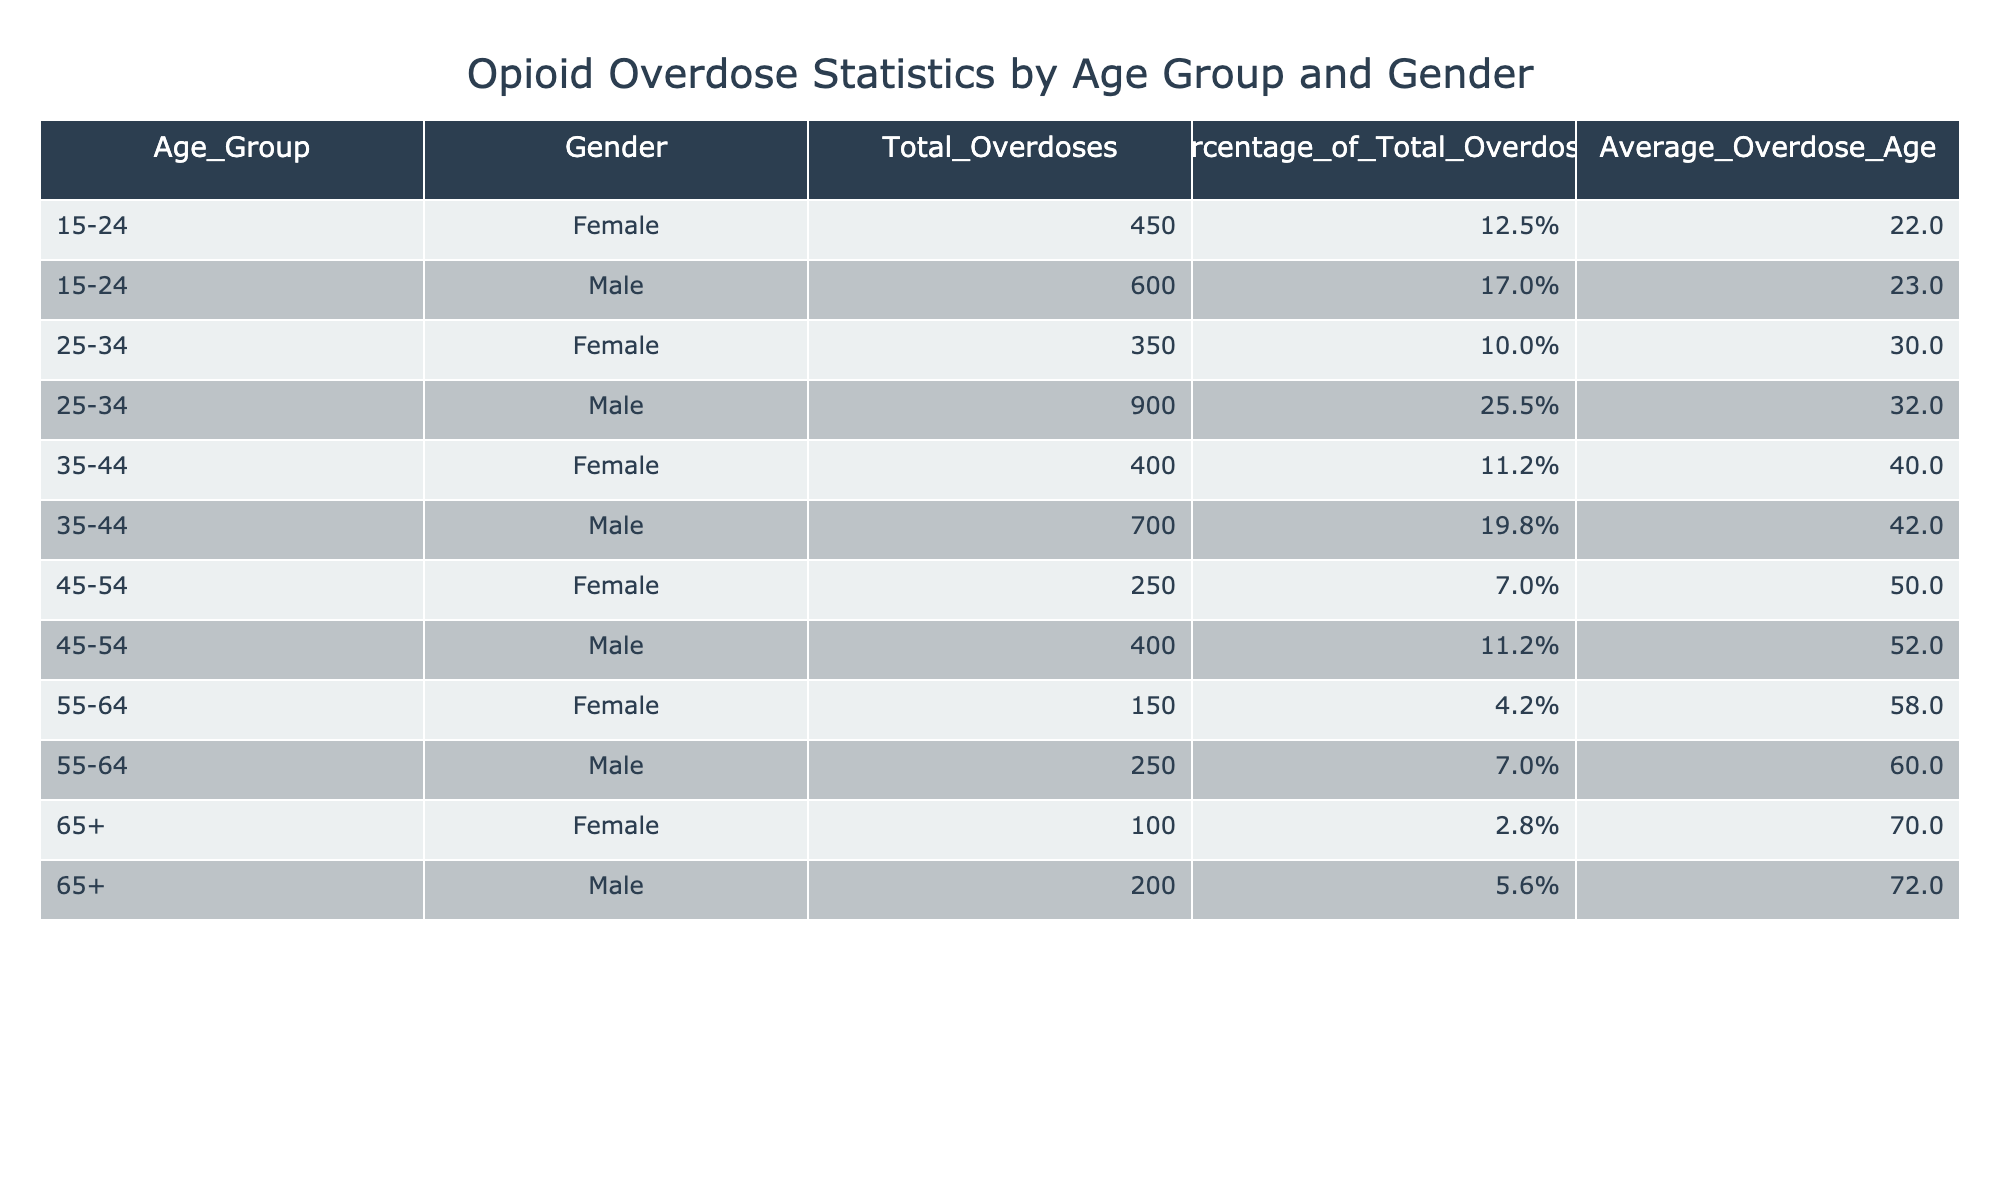What is the total number of overdoses among males aged 15-24? Referring to the table, under the age group 15-24, the number of overdoses for males is listed as 600.
Answer: 600 What percentage of total overdoses do females in the 25-34 age group account for? In the table, the percentage of total overdoses for females in the 25-34 age group is recorded as 10.0%.
Answer: 10.0% Which age group has the highest number of total overdoses? By examining the Total_Overdoses column, the age group 25-34 for males shows the highest total with 900 overdoses.
Answer: 25-34 Is the average overdose age for males in the 55-64 age group greater than that for females in the same age group? For males in the 55-64 age group, the Average_Overdose_Age is 60, while for females, it is 58. Since 60 is greater than 58, the statement is true.
Answer: Yes Calculate the total number of overdoses for females across all age groups. Summing the Total_Overdoses for females: 450 (15-24) + 350 (25-34) + 400 (35-44) + 250 (45-54) + 150 (55-64) + 100 (65+) gives 1,700.
Answer: 1700 What is the average overdose age of all males aged 45-54? The Average_Overdose_Age for males in the 45-54 age group is 52.
Answer: 52 Does the number of overdoses for males aged 65 and older exceed those for females in the same age category? Looking at the Total_Overdoses column, males aged 65+ have 200 overdoses while females have 100. Since 200 is greater than 100, the statement is true.
Answer: Yes What is the difference in overdose numbers between the oldest males (65+) and the youngest females (15-24)? The Total_Overdoses for males aged 65+ is 200, and for females aged 15-24, it is 450. The difference is 450 - 200 = 250.
Answer: 250 How many more overdoses did males aged 25-34 have compared to males aged 35-44? From the table, males in the 25-34 age group had 900 overdoses, and those in the 35-44 age group had 700. Calculating the difference: 900 - 700 = 200.
Answer: 200 What is the total percentage of overdoses for the 45-54 age group across both genders? For the 45-54 age group, females account for 7.0% and males account for 11.2%. Adding these gives 7.0% + 11.2% = 18.2%.
Answer: 18.2% 